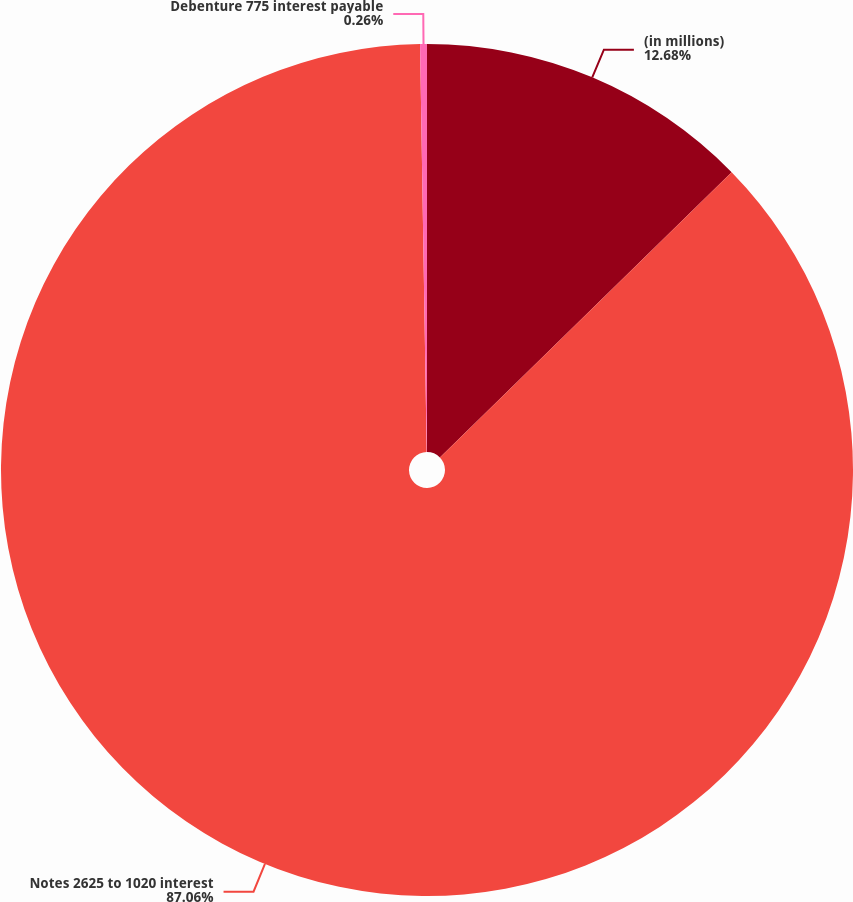Convert chart to OTSL. <chart><loc_0><loc_0><loc_500><loc_500><pie_chart><fcel>(in millions)<fcel>Notes 2625 to 1020 interest<fcel>Debenture 775 interest payable<nl><fcel>12.68%<fcel>87.05%<fcel>0.26%<nl></chart> 